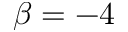<formula> <loc_0><loc_0><loc_500><loc_500>\beta = - 4</formula> 